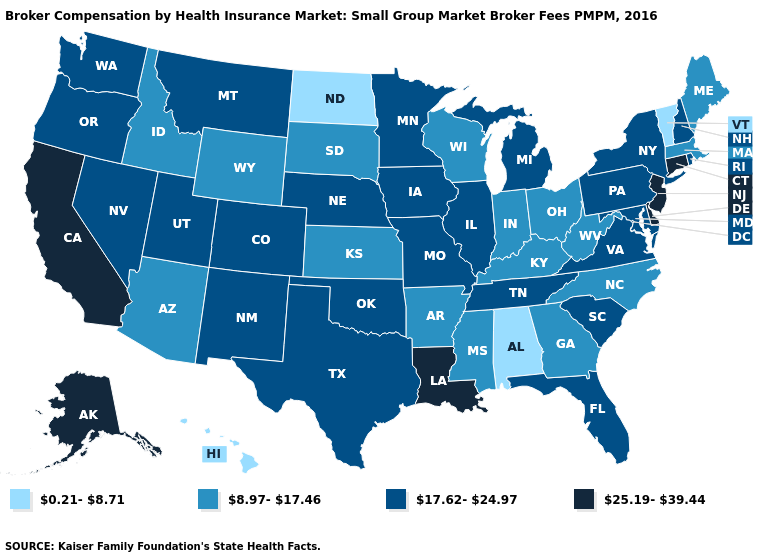Name the states that have a value in the range 0.21-8.71?
Keep it brief. Alabama, Hawaii, North Dakota, Vermont. What is the value of Tennessee?
Be succinct. 17.62-24.97. Among the states that border West Virginia , does Kentucky have the lowest value?
Keep it brief. Yes. Name the states that have a value in the range 25.19-39.44?
Be succinct. Alaska, California, Connecticut, Delaware, Louisiana, New Jersey. What is the highest value in states that border Texas?
Short answer required. 25.19-39.44. Does Kansas have the highest value in the MidWest?
Concise answer only. No. Which states have the lowest value in the USA?
Answer briefly. Alabama, Hawaii, North Dakota, Vermont. Name the states that have a value in the range 8.97-17.46?
Write a very short answer. Arizona, Arkansas, Georgia, Idaho, Indiana, Kansas, Kentucky, Maine, Massachusetts, Mississippi, North Carolina, Ohio, South Dakota, West Virginia, Wisconsin, Wyoming. Which states have the lowest value in the South?
Write a very short answer. Alabama. What is the value of Nebraska?
Short answer required. 17.62-24.97. Does Vermont have a lower value than Alabama?
Keep it brief. No. Name the states that have a value in the range 0.21-8.71?
Keep it brief. Alabama, Hawaii, North Dakota, Vermont. Which states have the lowest value in the USA?
Answer briefly. Alabama, Hawaii, North Dakota, Vermont. Does Hawaii have the lowest value in the USA?
Write a very short answer. Yes. Does Kansas have the lowest value in the MidWest?
Write a very short answer. No. 